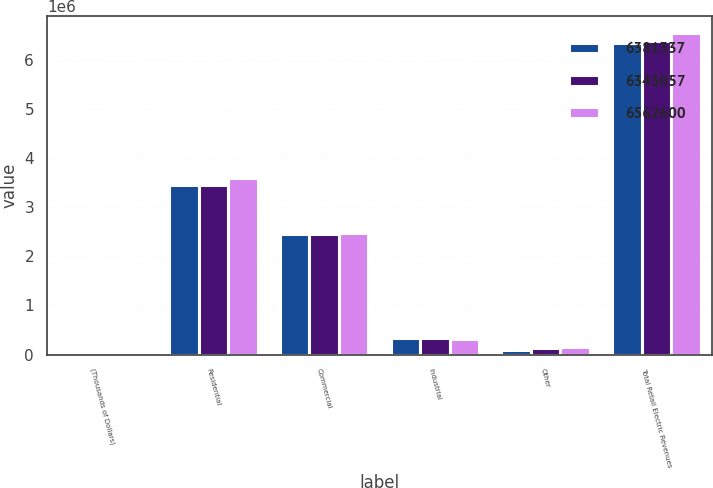Convert chart. <chart><loc_0><loc_0><loc_500><loc_500><stacked_bar_chart><ecel><fcel>(Thousands of Dollars)<fcel>Residential<fcel>Commercial<fcel>Industrial<fcel>Other<fcel>Total Retail Electric Revenues<nl><fcel>6.38134e+06<fcel>2017<fcel>3.45799e+06<fcel>2.45998e+06<fcel>330995<fcel>94091<fcel>6.34306e+06<nl><fcel>6.34306e+06<fcel>2016<fcel>3.44804e+06<fcel>2.46566e+06<fcel>328103<fcel>139527<fcel>6.38134e+06<nl><fcel>6.5626e+06<fcel>2015<fcel>3.60816e+06<fcel>2.47669e+06<fcel>326564<fcel>151195<fcel>6.5626e+06<nl></chart> 